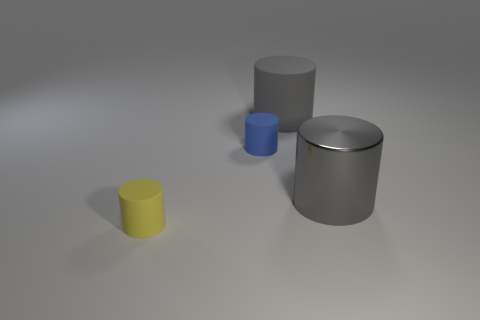Subtract 1 cylinders. How many cylinders are left? 3 Add 2 big gray metallic cylinders. How many objects exist? 6 Subtract 0 green cylinders. How many objects are left? 4 Subtract all small rubber cylinders. Subtract all gray things. How many objects are left? 0 Add 2 yellow rubber cylinders. How many yellow rubber cylinders are left? 3 Add 1 small blue things. How many small blue things exist? 2 